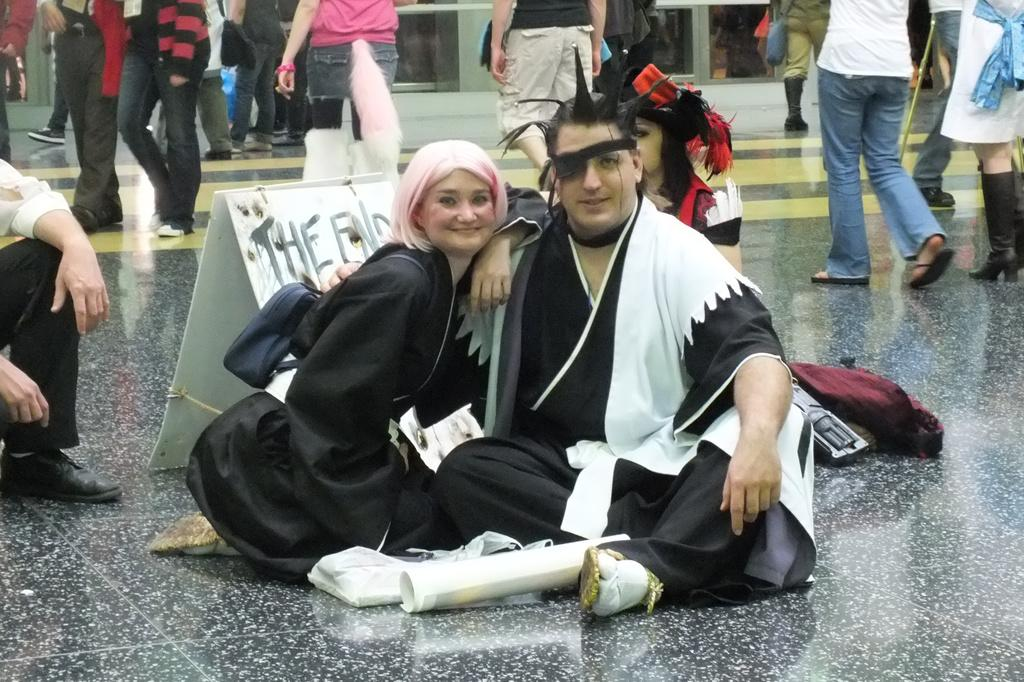What are the people in the image doing? The people sitting on the floor are posing for a photo. What is the position of the people in the image? The people are sitting on the floor. Are there any other activities happening in the image? Yes, there are many people walking on the floor in the image. What type of farm can be seen in the background of the image? There is no farm visible in the image; it features people sitting and walking on the floor. Who is the creator of the people in the image? The question is not applicable, as the people in the image are real individuals and not created entities. 